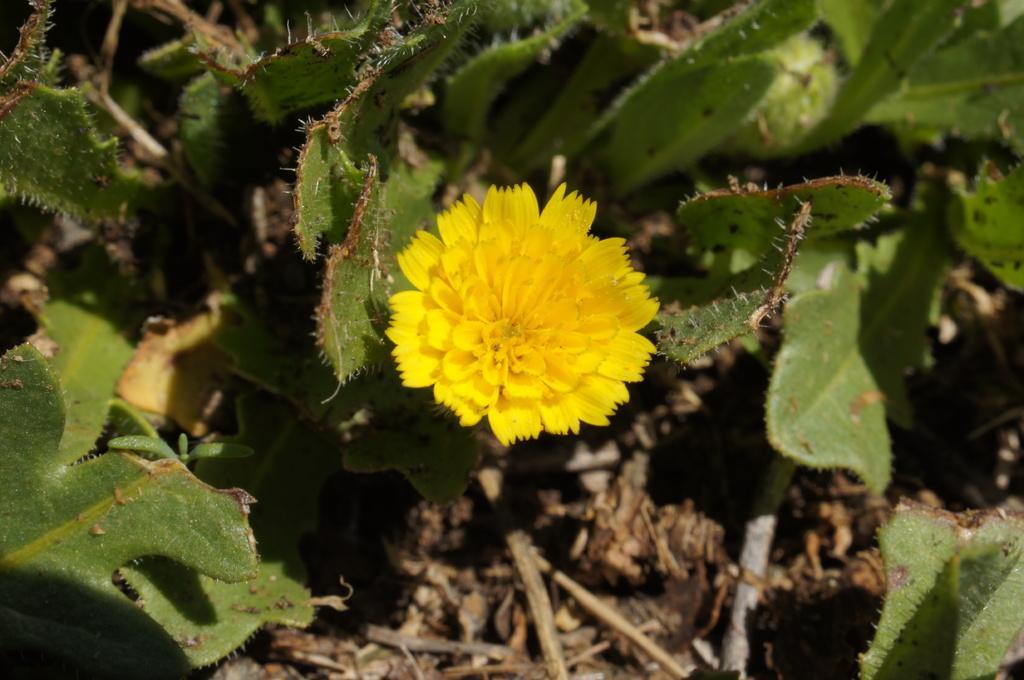Can you describe this image briefly? In this image there is a plant having a flower. Background there are plants on the land. 